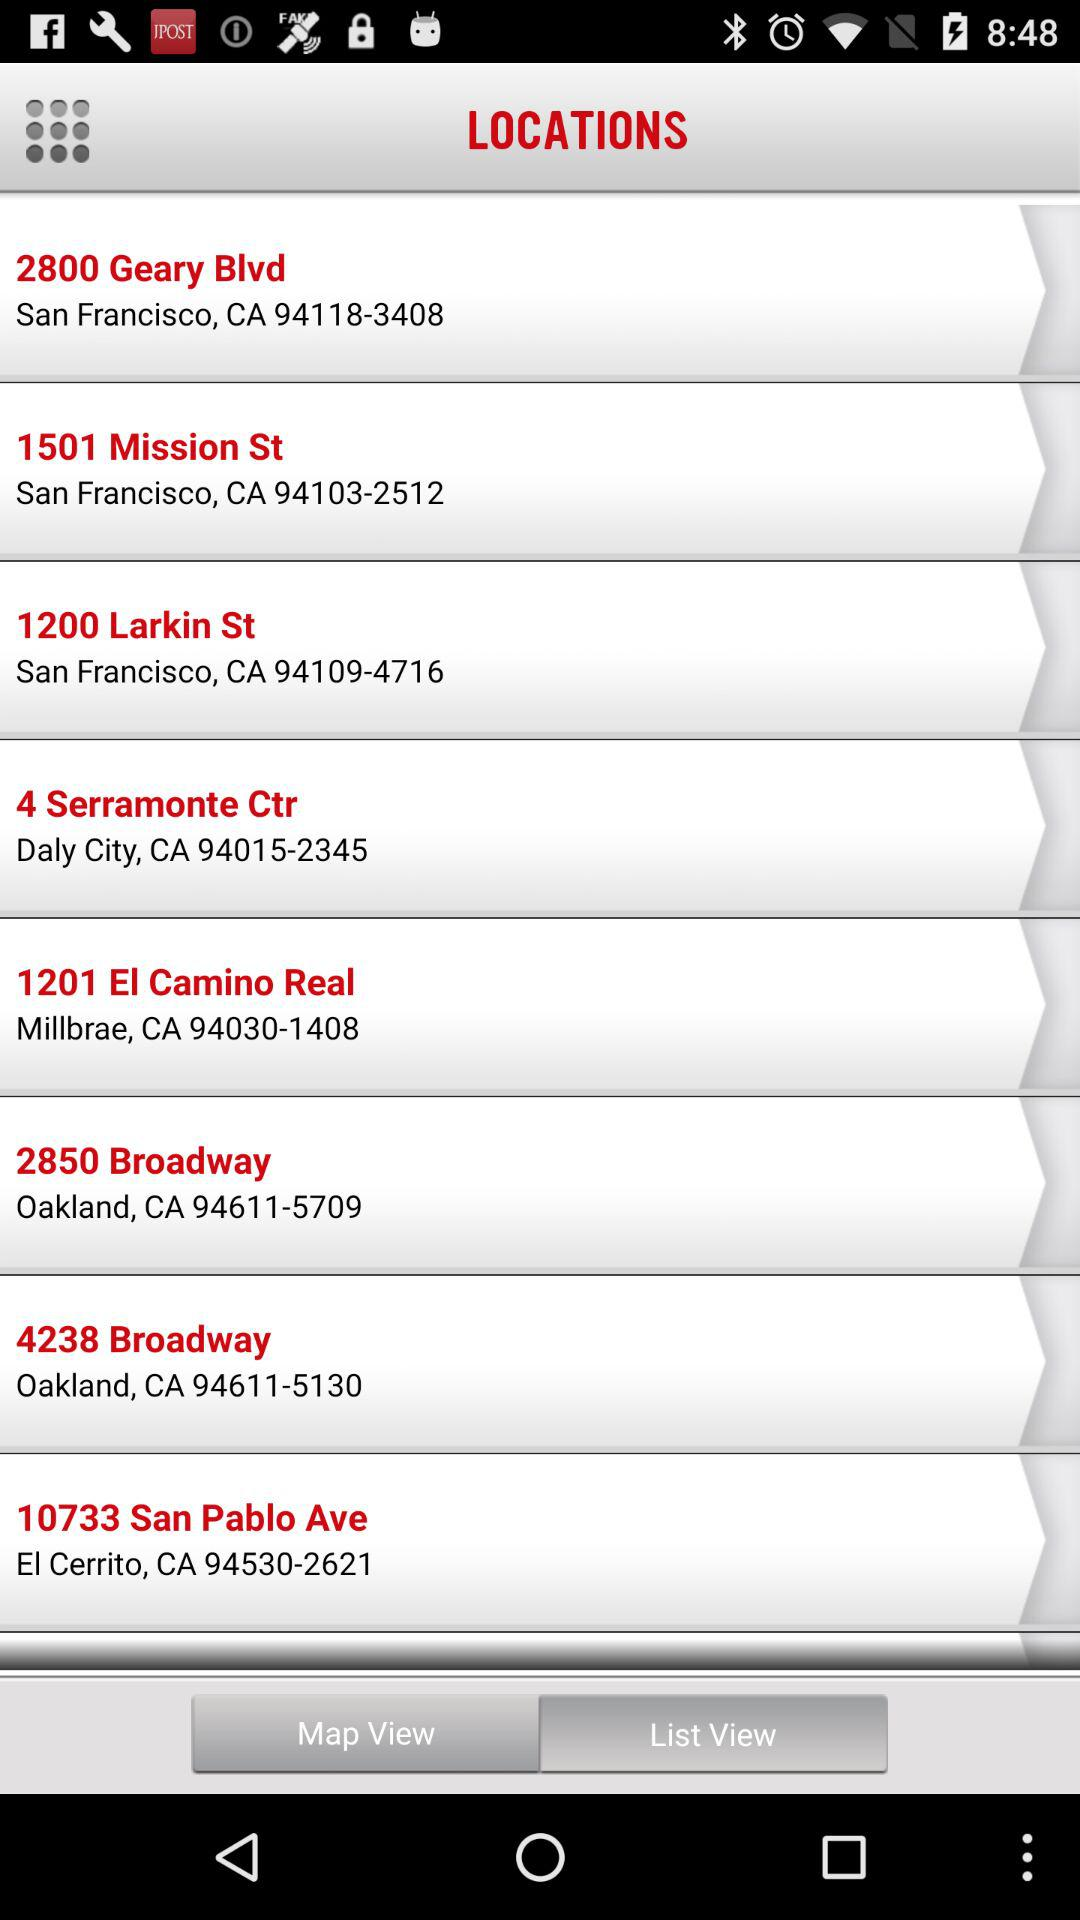How many locations are in Oakland?
Answer the question using a single word or phrase. 2 